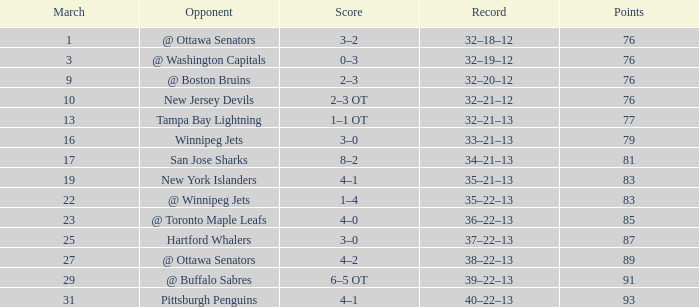How many games have a March of 19, and Points smaller than 83? 0.0. 